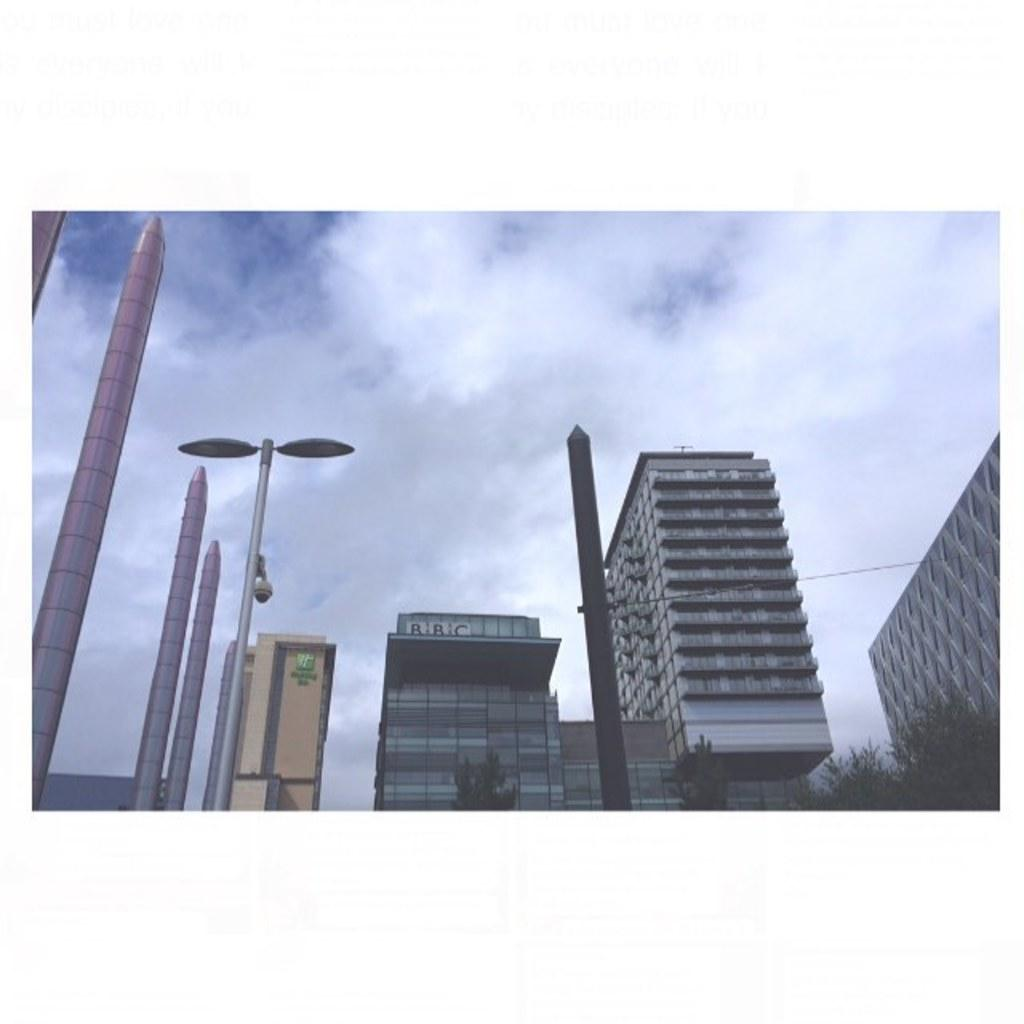What type of structures can be seen in the image? There are many buildings visible in the image. What else can be seen in the image besides buildings? There are poles and trees in the image. From what perspective is the image taken? The view is from the bottom. How would you describe the sky in the image? The sky is blue with white clouds. Where is the drum located in the image? There is no drum present in the image. What type of lead can be seen in the image? There is no lead present in the image. 